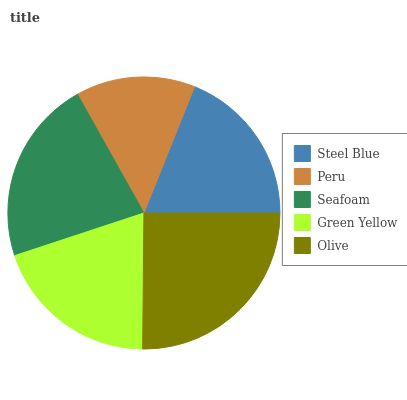Is Peru the minimum?
Answer yes or no. Yes. Is Olive the maximum?
Answer yes or no. Yes. Is Seafoam the minimum?
Answer yes or no. No. Is Seafoam the maximum?
Answer yes or no. No. Is Seafoam greater than Peru?
Answer yes or no. Yes. Is Peru less than Seafoam?
Answer yes or no. Yes. Is Peru greater than Seafoam?
Answer yes or no. No. Is Seafoam less than Peru?
Answer yes or no. No. Is Green Yellow the high median?
Answer yes or no. Yes. Is Green Yellow the low median?
Answer yes or no. Yes. Is Olive the high median?
Answer yes or no. No. Is Steel Blue the low median?
Answer yes or no. No. 